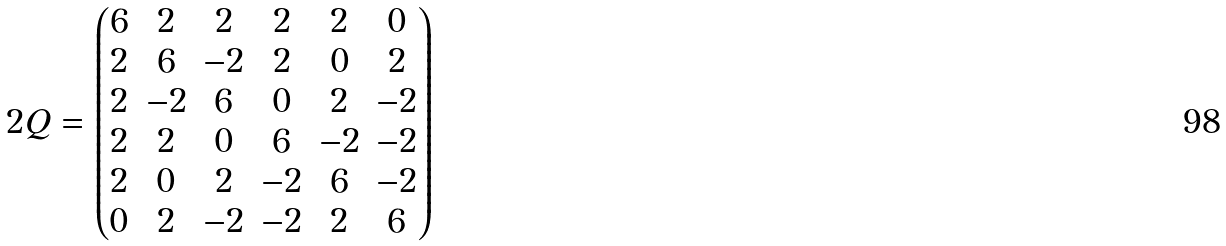<formula> <loc_0><loc_0><loc_500><loc_500>2 Q = \begin{pmatrix} 6 & 2 & 2 & 2 & 2 & 0 \\ 2 & 6 & - 2 & 2 & 0 & 2 \\ 2 & - 2 & 6 & 0 & 2 & - 2 \\ 2 & 2 & 0 & 6 & - 2 & - 2 \\ 2 & 0 & 2 & - 2 & 6 & - 2 \\ 0 & 2 & - 2 & - 2 & 2 & 6 \end{pmatrix}</formula> 